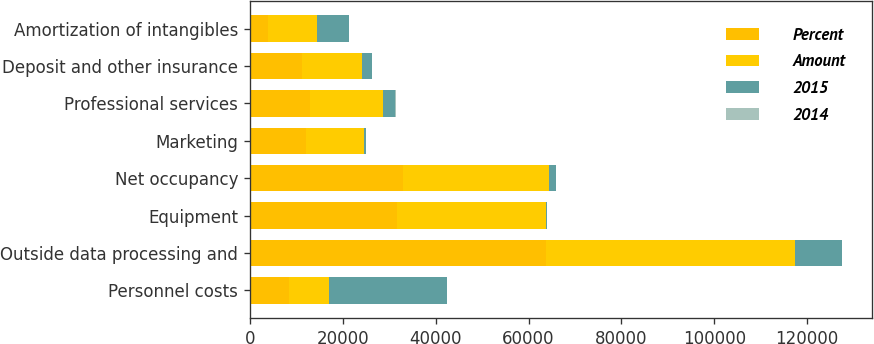Convert chart to OTSL. <chart><loc_0><loc_0><loc_500><loc_500><stacked_bar_chart><ecel><fcel>Personnel costs<fcel>Outside data processing and<fcel>Equipment<fcel>Net occupancy<fcel>Marketing<fcel>Professional services<fcel>Deposit and other insurance<fcel>Amortization of intangibles<nl><fcel>Percent<fcel>8477.5<fcel>63775<fcel>31711<fcel>32939<fcel>12035<fcel>13010<fcel>11105<fcel>3788<nl><fcel>Amount<fcel>8477.5<fcel>53685<fcel>31981<fcel>31565<fcel>12466<fcel>15665<fcel>13099<fcel>10653<nl><fcel>2015<fcel>25572<fcel>10090<fcel>270<fcel>1374<fcel>431<fcel>2655<fcel>1994<fcel>6865<nl><fcel>2014<fcel>10<fcel>19<fcel>1<fcel>4<fcel>3<fcel>17<fcel>15<fcel>64<nl></chart> 